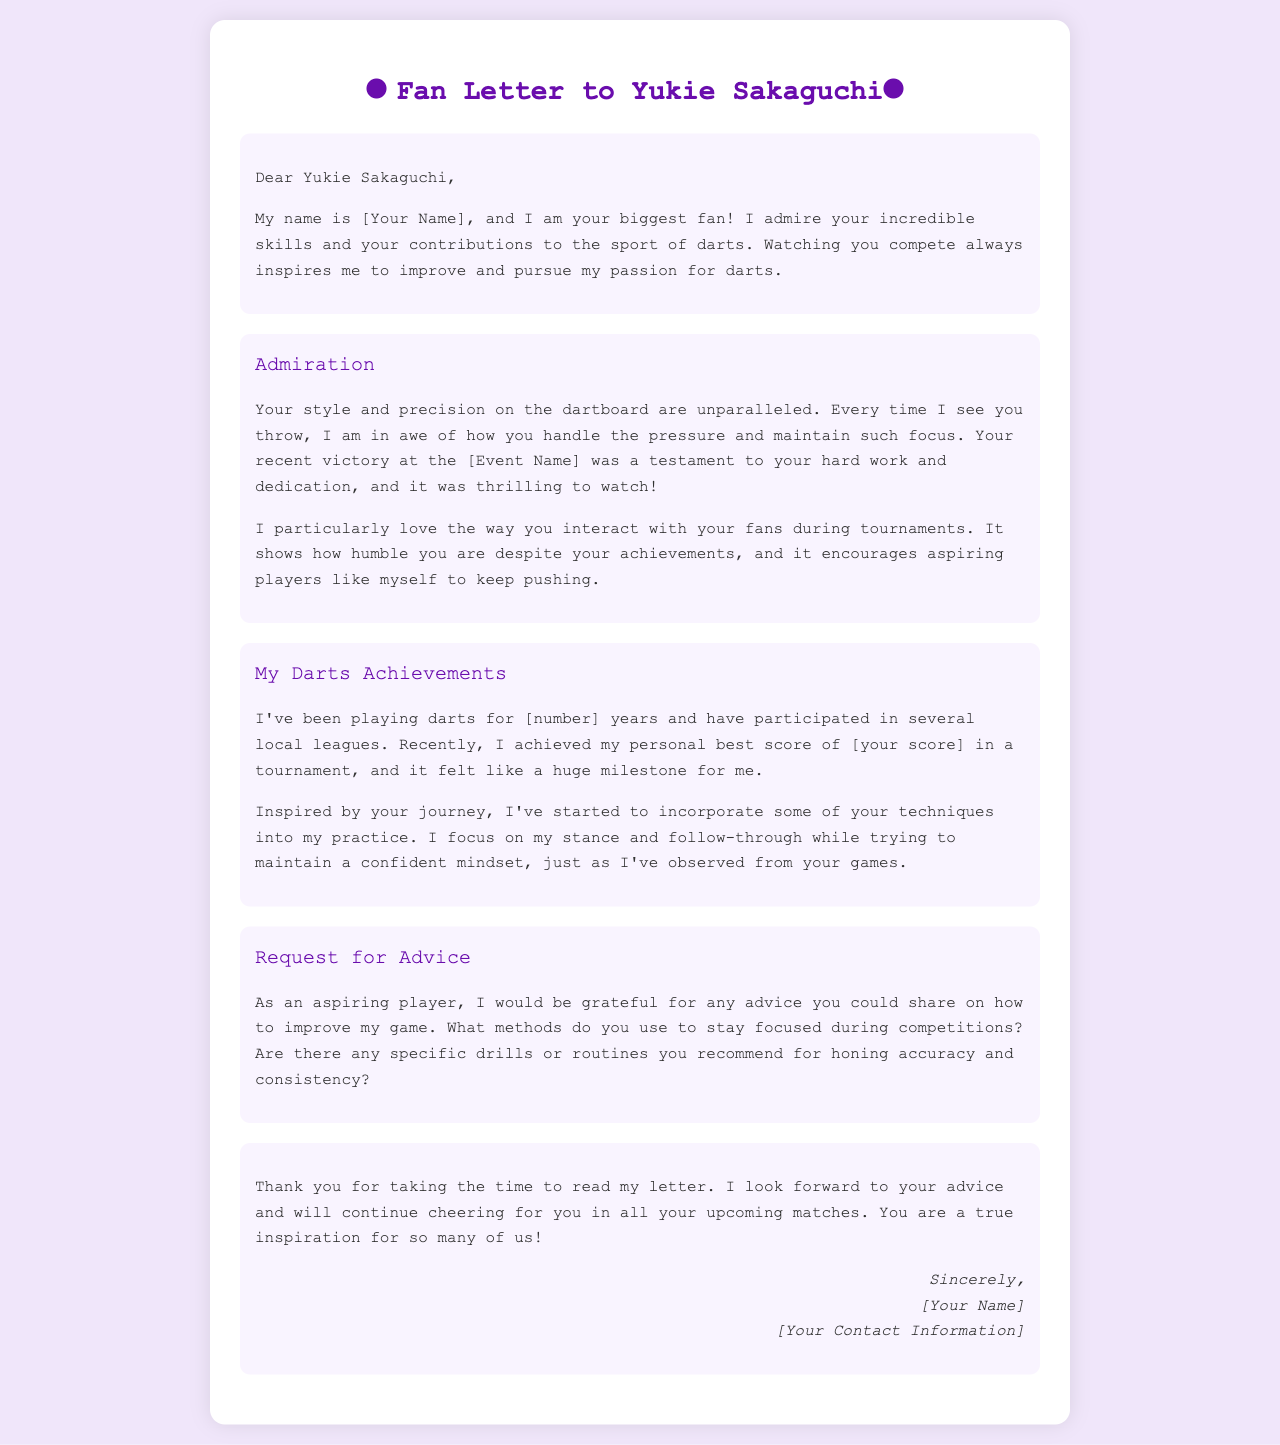What is the name of the fan addressed in the letter? The letter does not specify a name for the fan, but it mentions "[Your Name]" where a name would be included.
Answer: [Your Name] What sport does Yukie Sakaguchi participate in? The letter indicates that Yukie Sakaguchi is involved in the sport of darts.
Answer: Darts How many years has the fan been playing darts? The document specifies that the fan has been playing darts for "[number]" years, indicating a placeholder for the actual duration.
Answer: [number] What was the fan's personal best score in a tournament? The fan mentions achieving a personal best score of "[your score]," which is a placeholder for the actual score.
Answer: [your score] What recent event is mentioned in the letter? The letter refers to a recent victory at "[Event Name]," indicating a placeholder where the actual event name would be included.
Answer: [Event Name] What advice does the fan request from Yukie Sakaguchi? The fan requests advice on improving their game, particularly focused on staying focused during competitions and specific drills or routines.
Answer: Improving game focus and drills What color is the headline text in the letter? The headline text color is specified as "#6a0dad," which is a shade of purple.
Answer: Purple What type of document is this? The structure and content of the document clearly indicate that it is a fan letter addressed to Yukie Sakaguchi.
Answer: Fan letter 